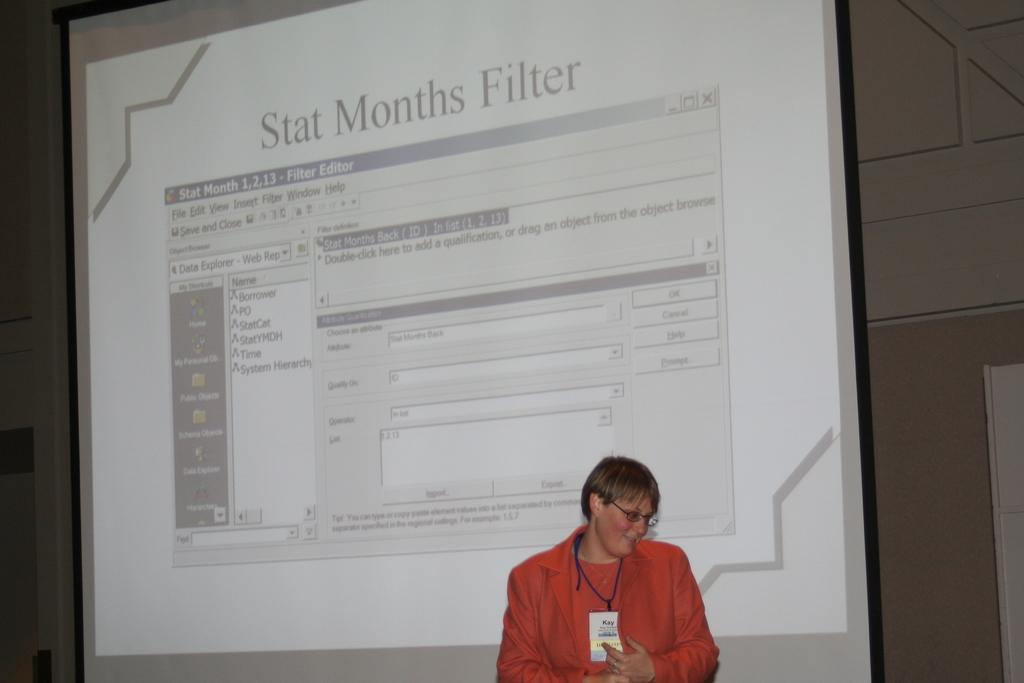Could you give a brief overview of what you see in this image? In this image we can see a woman and she wore spectacles. In the background we can see a screen and a wall. On the screen we can see app icons and some information. 